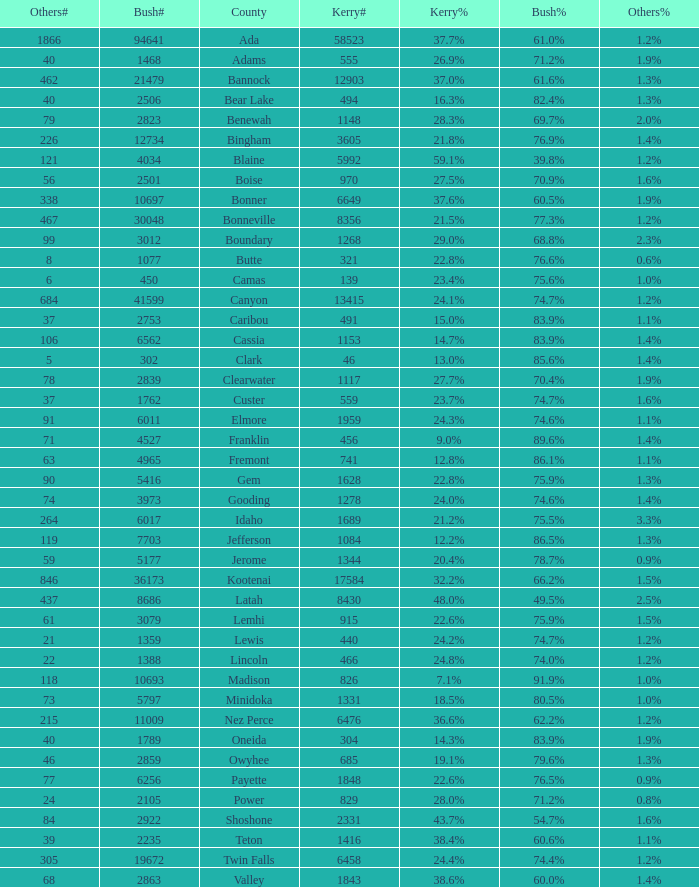What's percentage voted for Busg in the county where Kerry got 37.6%? 60.5%. 